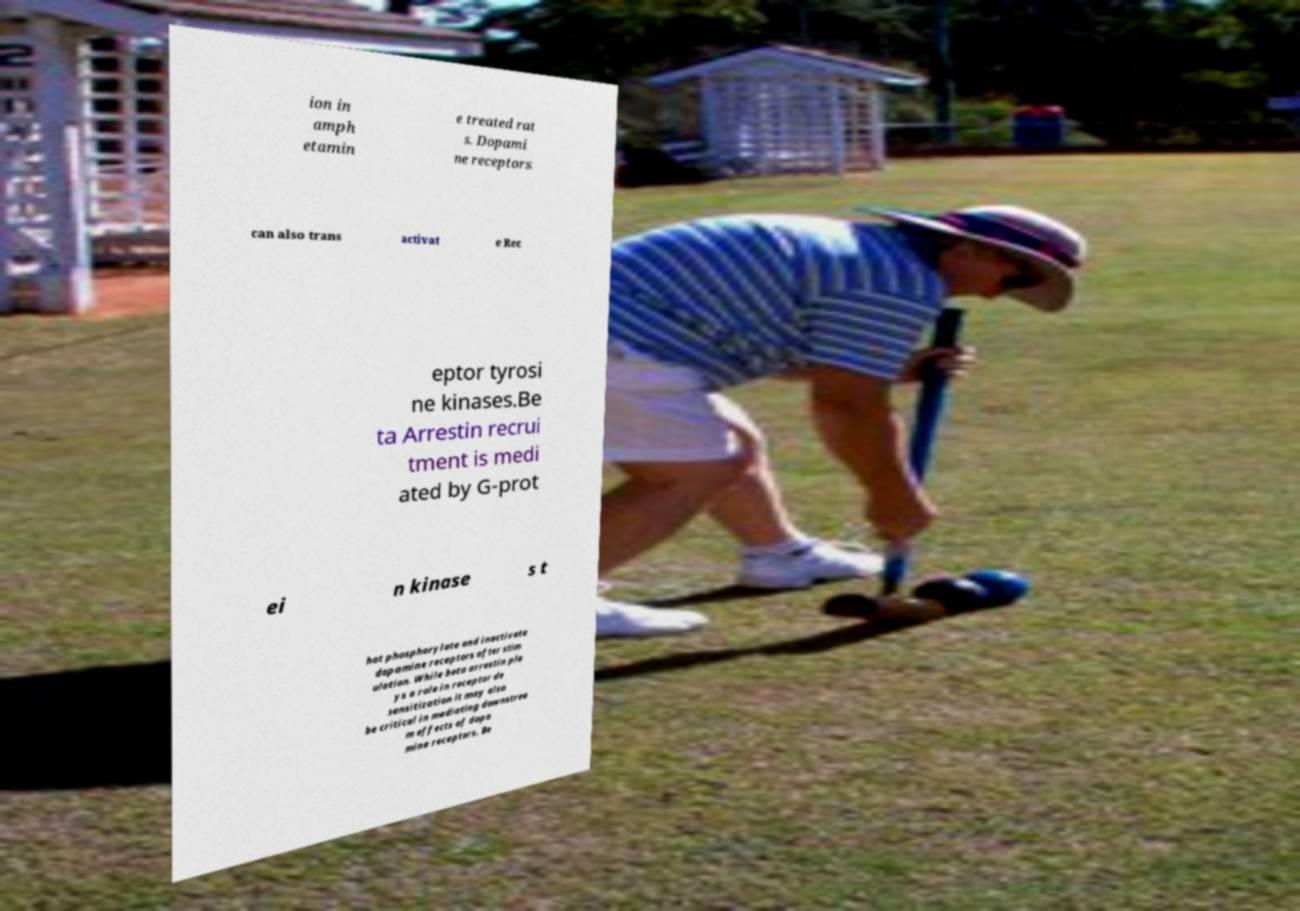Can you accurately transcribe the text from the provided image for me? ion in amph etamin e treated rat s. Dopami ne receptors can also trans activat e Rec eptor tyrosi ne kinases.Be ta Arrestin recrui tment is medi ated by G-prot ei n kinase s t hat phosphorylate and inactivate dopamine receptors after stim ulation. While beta arrestin pla ys a role in receptor de sensitization it may also be critical in mediating downstrea m effects of dopa mine receptors. Be 